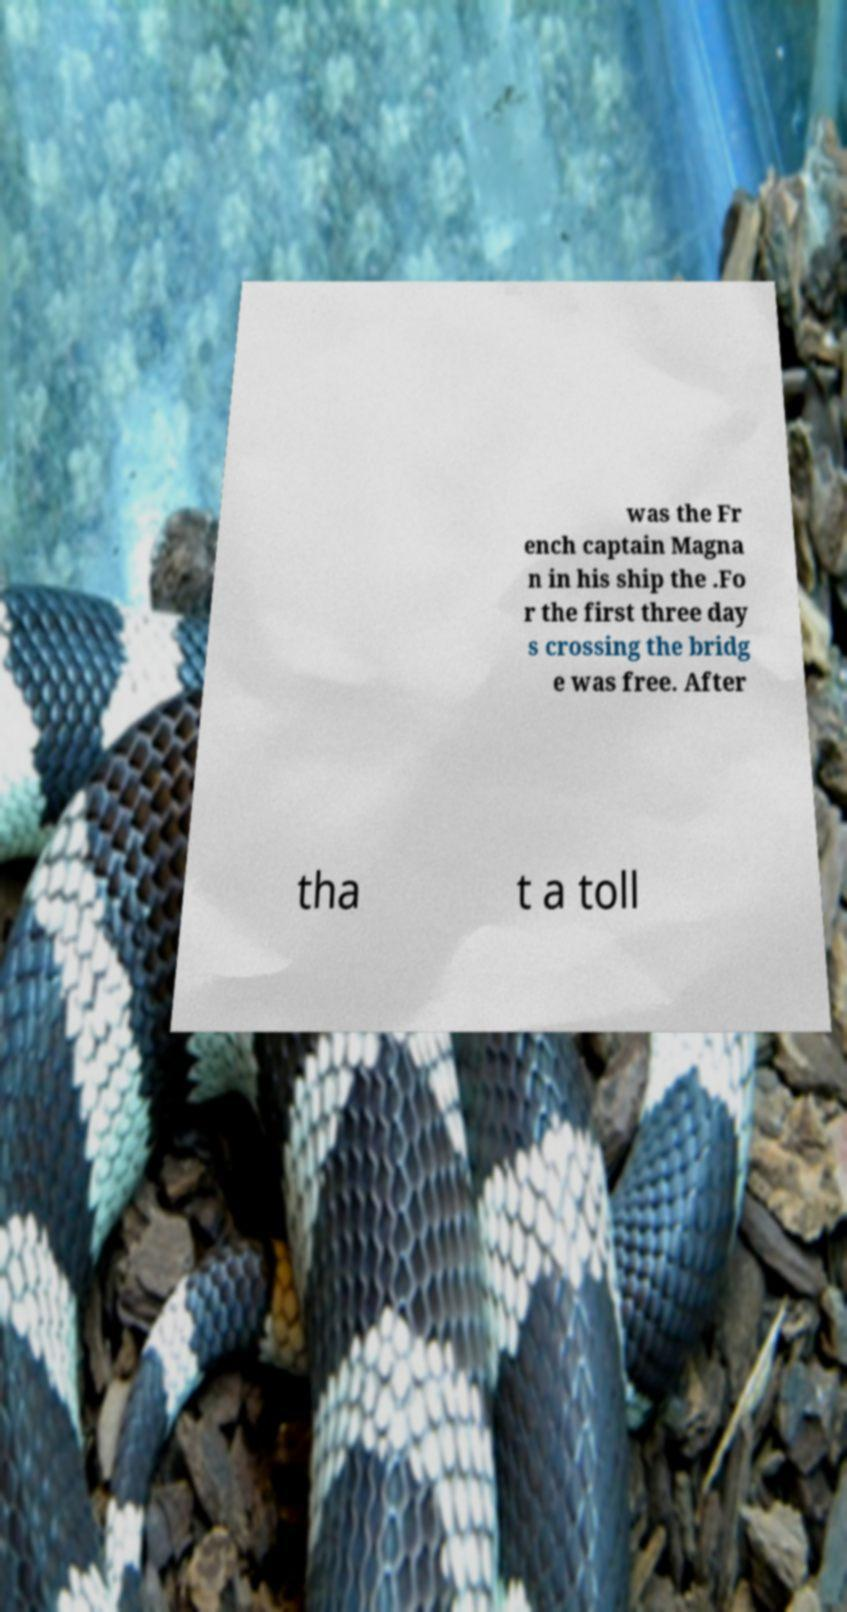There's text embedded in this image that I need extracted. Can you transcribe it verbatim? was the Fr ench captain Magna n in his ship the .Fo r the first three day s crossing the bridg e was free. After tha t a toll 